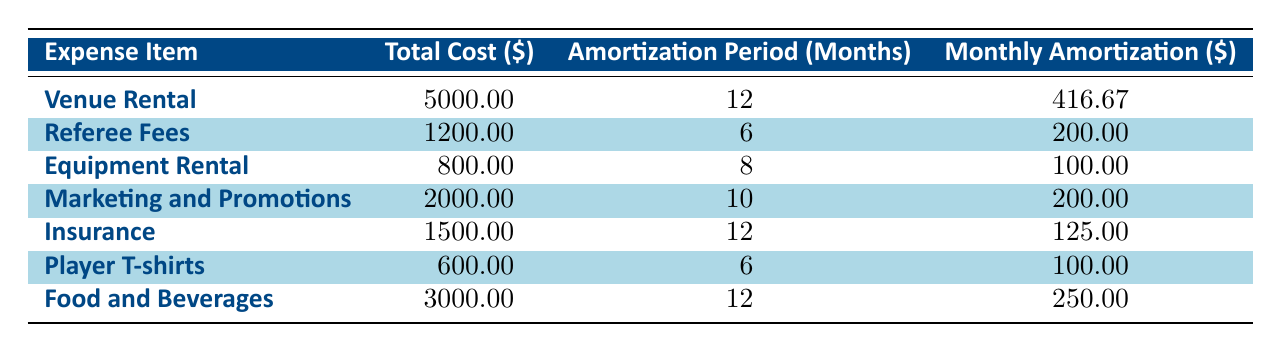What's the total cost of Venue Rental? The table lists Venue Rental with a total cost of 5000.00 in the second column.
Answer: 5000.00 How long is the amortization period for Equipment Rental? In the table, Equipment Rental is listed with an amortization period of 8 months in the third column.
Answer: 8 months What is the monthly amortization for Referee Fees? According to the table, Referee Fees have a monthly amortization of 200.00 which is stated in the fourth column.
Answer: 200.00 Are the total costs of Player T-shirts and Equipment Rental equal? The total cost of Player T-shirts is 600.00 and Equipment Rental is 800.00. Since 600.00 is not equal to 800.00, the statement is false.
Answer: No What is the average monthly amortization across all expense items? To calculate the average, first sum the monthly amortization values: 416.67 + 200.00 + 100.00 + 200.00 + 125.00 + 100.00 + 250.00 = 1391.67. There are 7 items, so the average is 1391.67 / 7 ≈ 198.81.
Answer: 198.81 Which expenses have an amortization period of 12 months? The table shows Venue Rental, Insurance, and Food and Beverages all have an amortization period of 12 months listed in the third column.
Answer: Venue Rental, Insurance, Food and Beverages What is the difference in total cost between the highest and the lowest expense items? The highest total cost is 5000.00 (Venue Rental) and the lowest is 600.00 (Player T-shirts). The difference is 5000.00 - 600.00 = 4400.00.
Answer: 4400.00 Is the monthly amortization for Marketing and Promotions greater than that for Food and Beverages? The table indicates the monthly amortization for Marketing and Promotions is 200.00 and for Food and Beverages is 250.00. Since 200.00 is less than 250.00, the statement is false.
Answer: No 